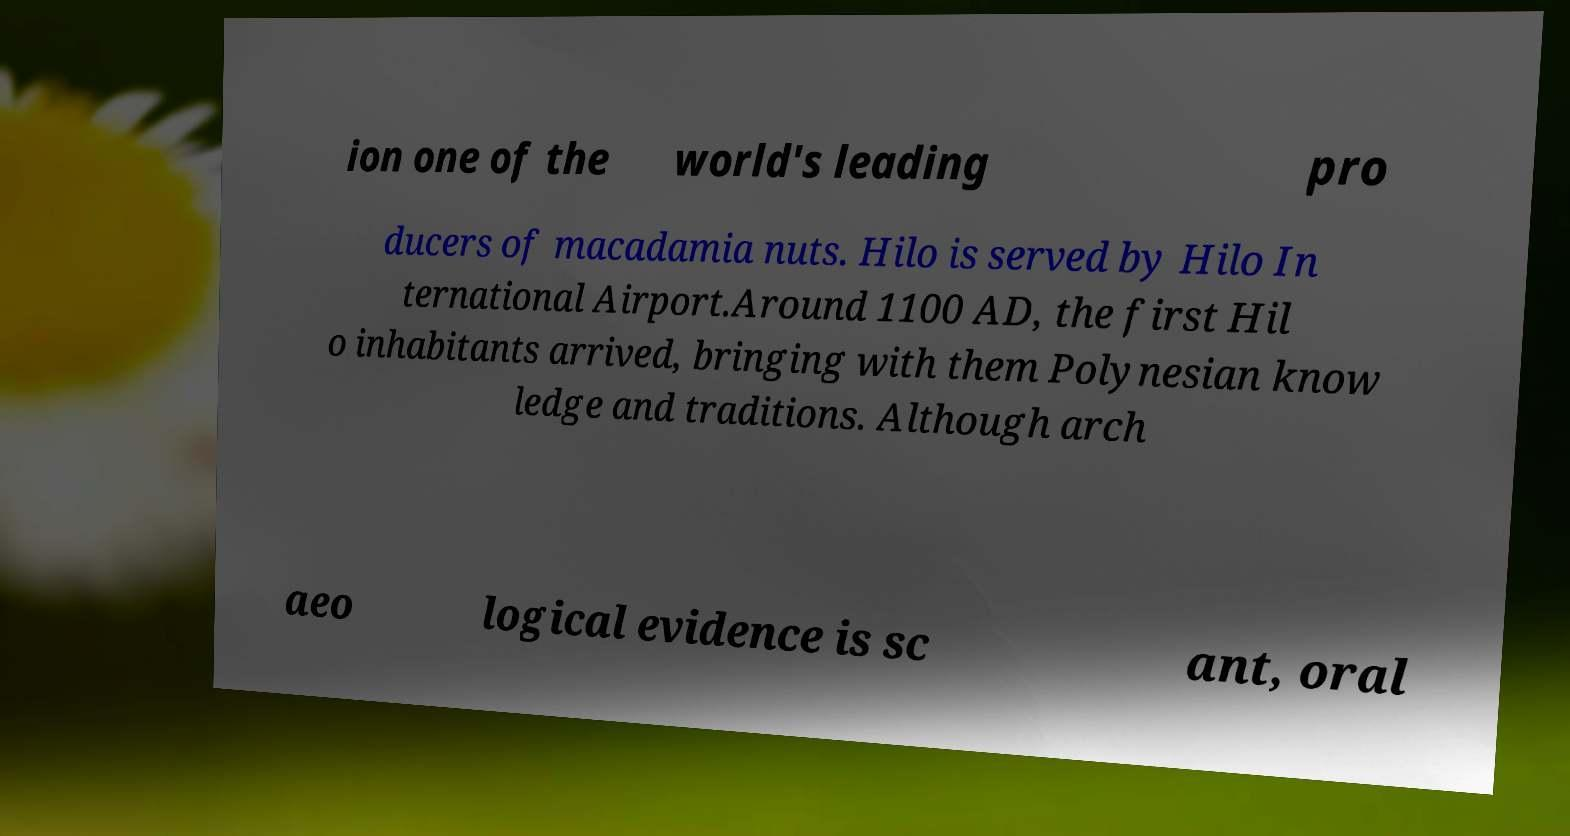Could you assist in decoding the text presented in this image and type it out clearly? ion one of the world's leading pro ducers of macadamia nuts. Hilo is served by Hilo In ternational Airport.Around 1100 AD, the first Hil o inhabitants arrived, bringing with them Polynesian know ledge and traditions. Although arch aeo logical evidence is sc ant, oral 